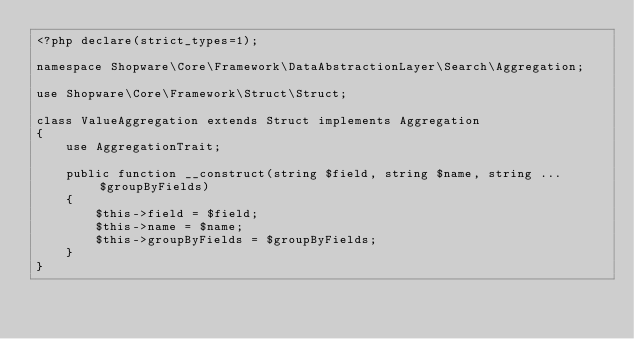Convert code to text. <code><loc_0><loc_0><loc_500><loc_500><_PHP_><?php declare(strict_types=1);

namespace Shopware\Core\Framework\DataAbstractionLayer\Search\Aggregation;

use Shopware\Core\Framework\Struct\Struct;

class ValueAggregation extends Struct implements Aggregation
{
    use AggregationTrait;

    public function __construct(string $field, string $name, string ...$groupByFields)
    {
        $this->field = $field;
        $this->name = $name;
        $this->groupByFields = $groupByFields;
    }
}
</code> 